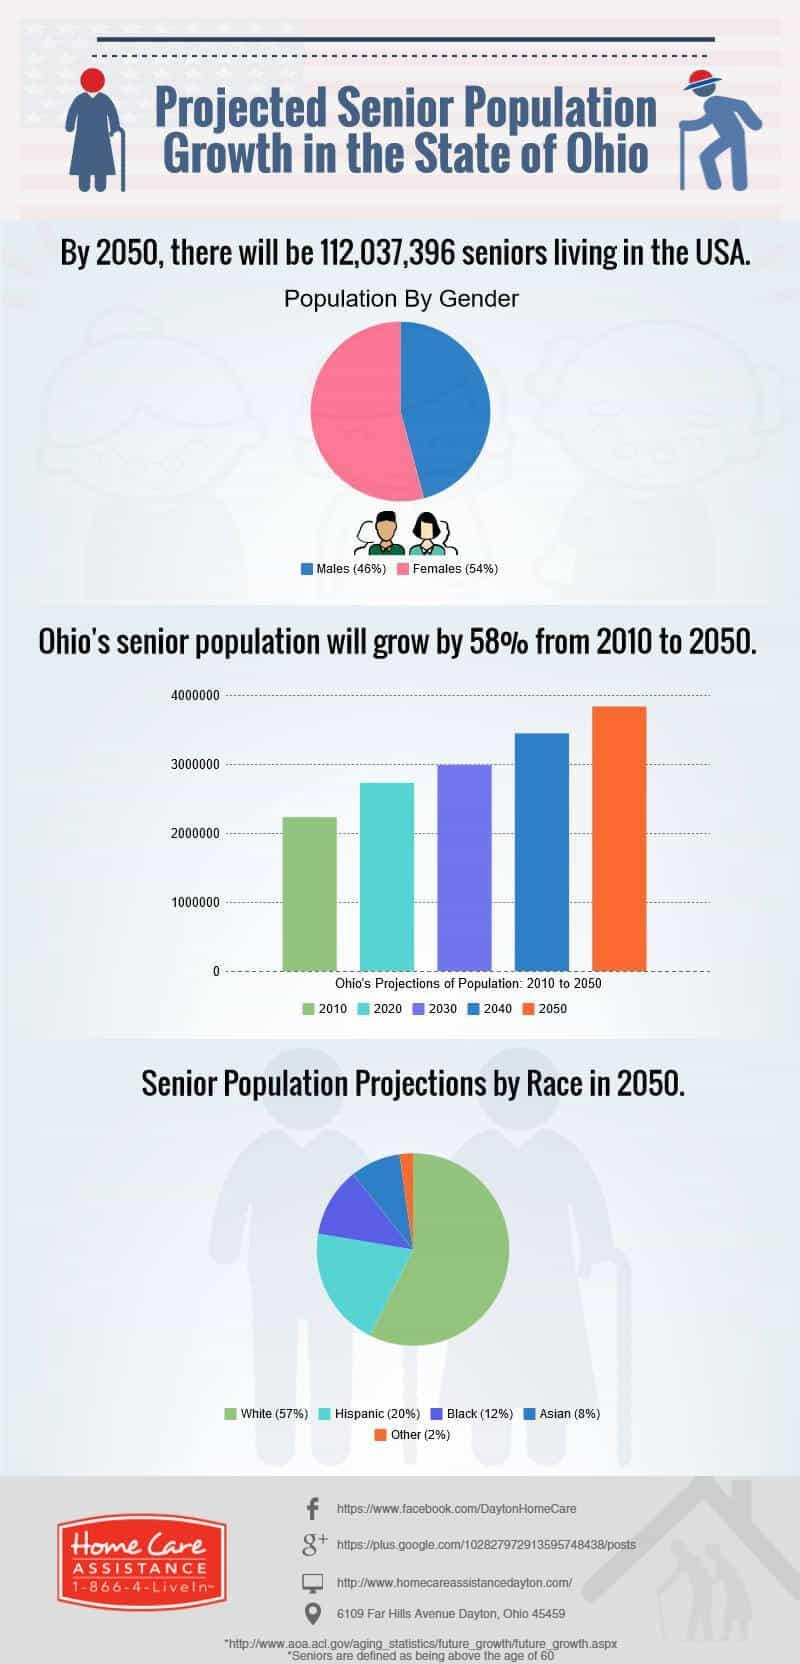In which year is Ohio's senior population estimated to be 3 million?
Answer the question with a short phrase. 2030 The second highest percent of senior population in 2050 will be of which ethnicity? Hispanic The second lowest percent of senior population in 2050 will be of which ethnicity? Asian The population of which gender will be higher by 2050? females 